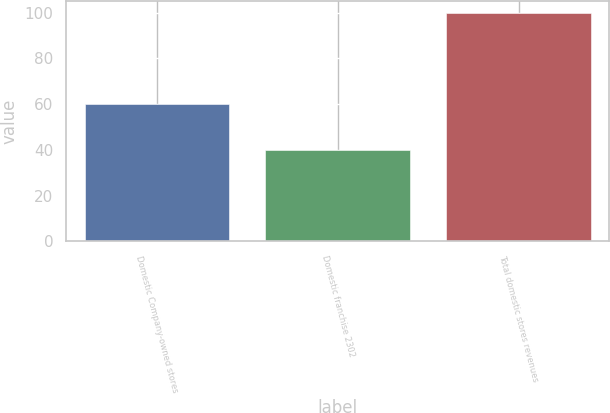Convert chart. <chart><loc_0><loc_0><loc_500><loc_500><bar_chart><fcel>Domestic Company-owned stores<fcel>Domestic franchise 2302<fcel>Total domestic stores revenues<nl><fcel>60.2<fcel>39.8<fcel>100<nl></chart> 